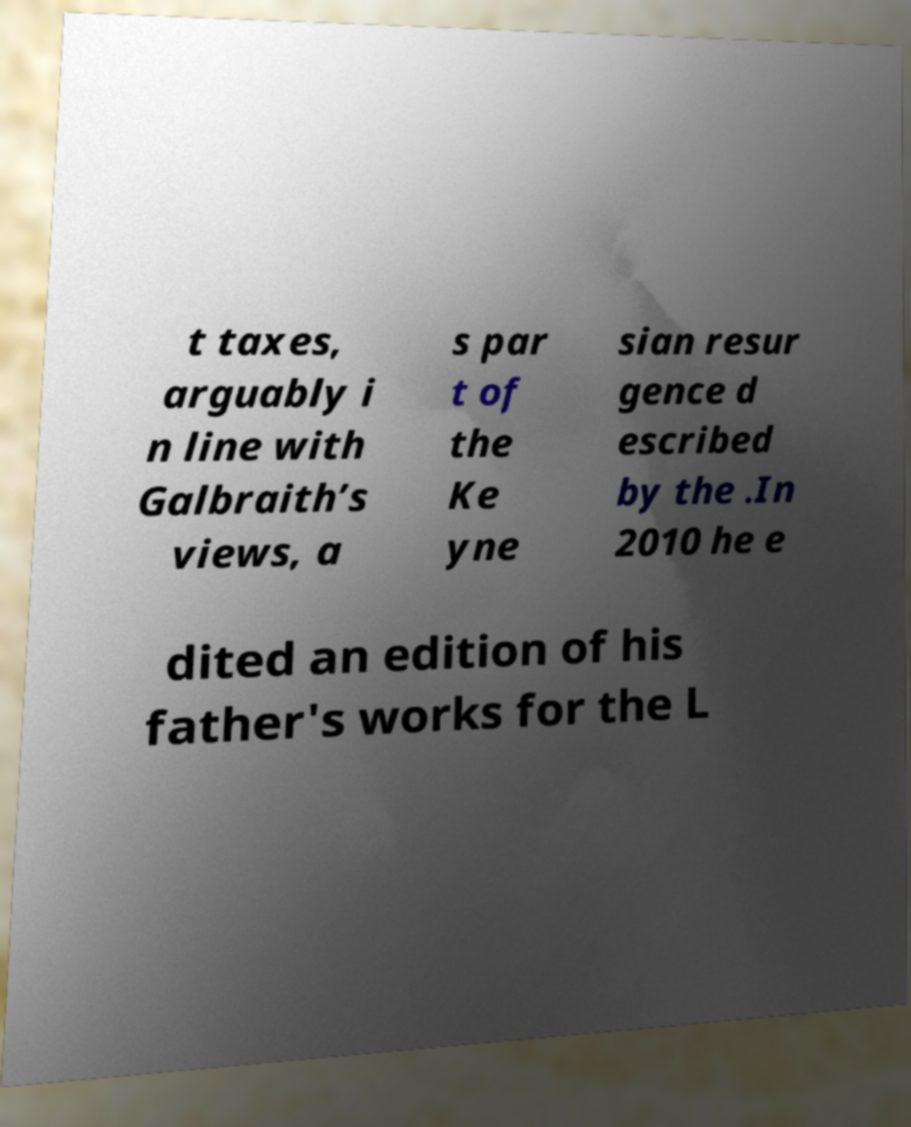Please identify and transcribe the text found in this image. t taxes, arguably i n line with Galbraith’s views, a s par t of the Ke yne sian resur gence d escribed by the .In 2010 he e dited an edition of his father's works for the L 